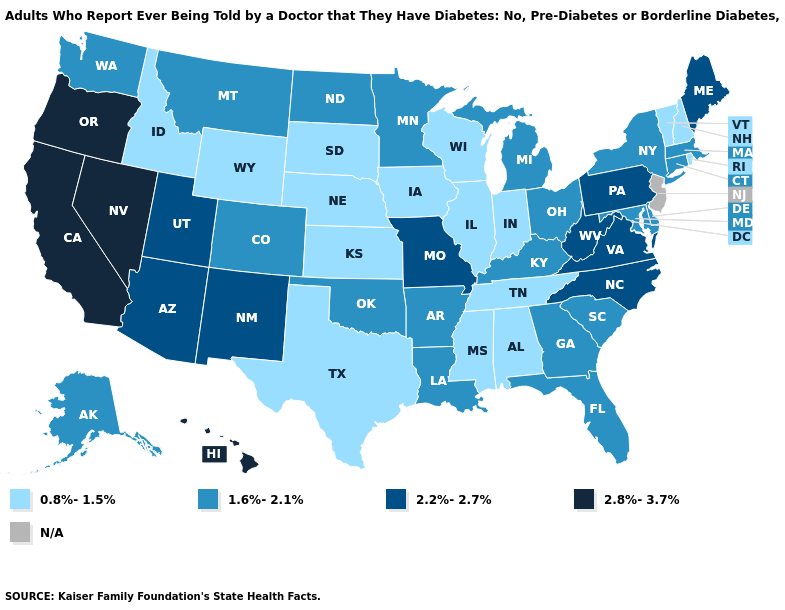What is the value of New Hampshire?
Give a very brief answer. 0.8%-1.5%. What is the value of North Dakota?
Short answer required. 1.6%-2.1%. Name the states that have a value in the range 1.6%-2.1%?
Short answer required. Alaska, Arkansas, Colorado, Connecticut, Delaware, Florida, Georgia, Kentucky, Louisiana, Maryland, Massachusetts, Michigan, Minnesota, Montana, New York, North Dakota, Ohio, Oklahoma, South Carolina, Washington. How many symbols are there in the legend?
Concise answer only. 5. What is the value of Nevada?
Short answer required. 2.8%-3.7%. How many symbols are there in the legend?
Short answer required. 5. What is the value of New Mexico?
Answer briefly. 2.2%-2.7%. What is the value of Ohio?
Quick response, please. 1.6%-2.1%. Which states have the lowest value in the Northeast?
Be succinct. New Hampshire, Rhode Island, Vermont. Among the states that border Arkansas , which have the highest value?
Short answer required. Missouri. Among the states that border Washington , which have the highest value?
Keep it brief. Oregon. What is the value of West Virginia?
Short answer required. 2.2%-2.7%. 